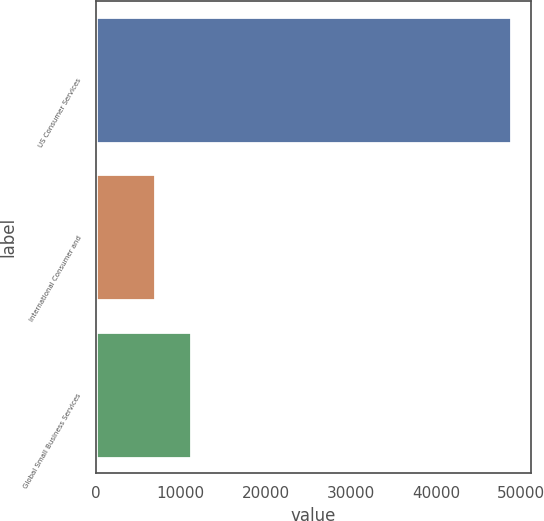Convert chart to OTSL. <chart><loc_0><loc_0><loc_500><loc_500><bar_chart><fcel>US Consumer Services<fcel>International Consumer and<fcel>Global Small Business Services<nl><fcel>48758<fcel>6971<fcel>11149.7<nl></chart> 